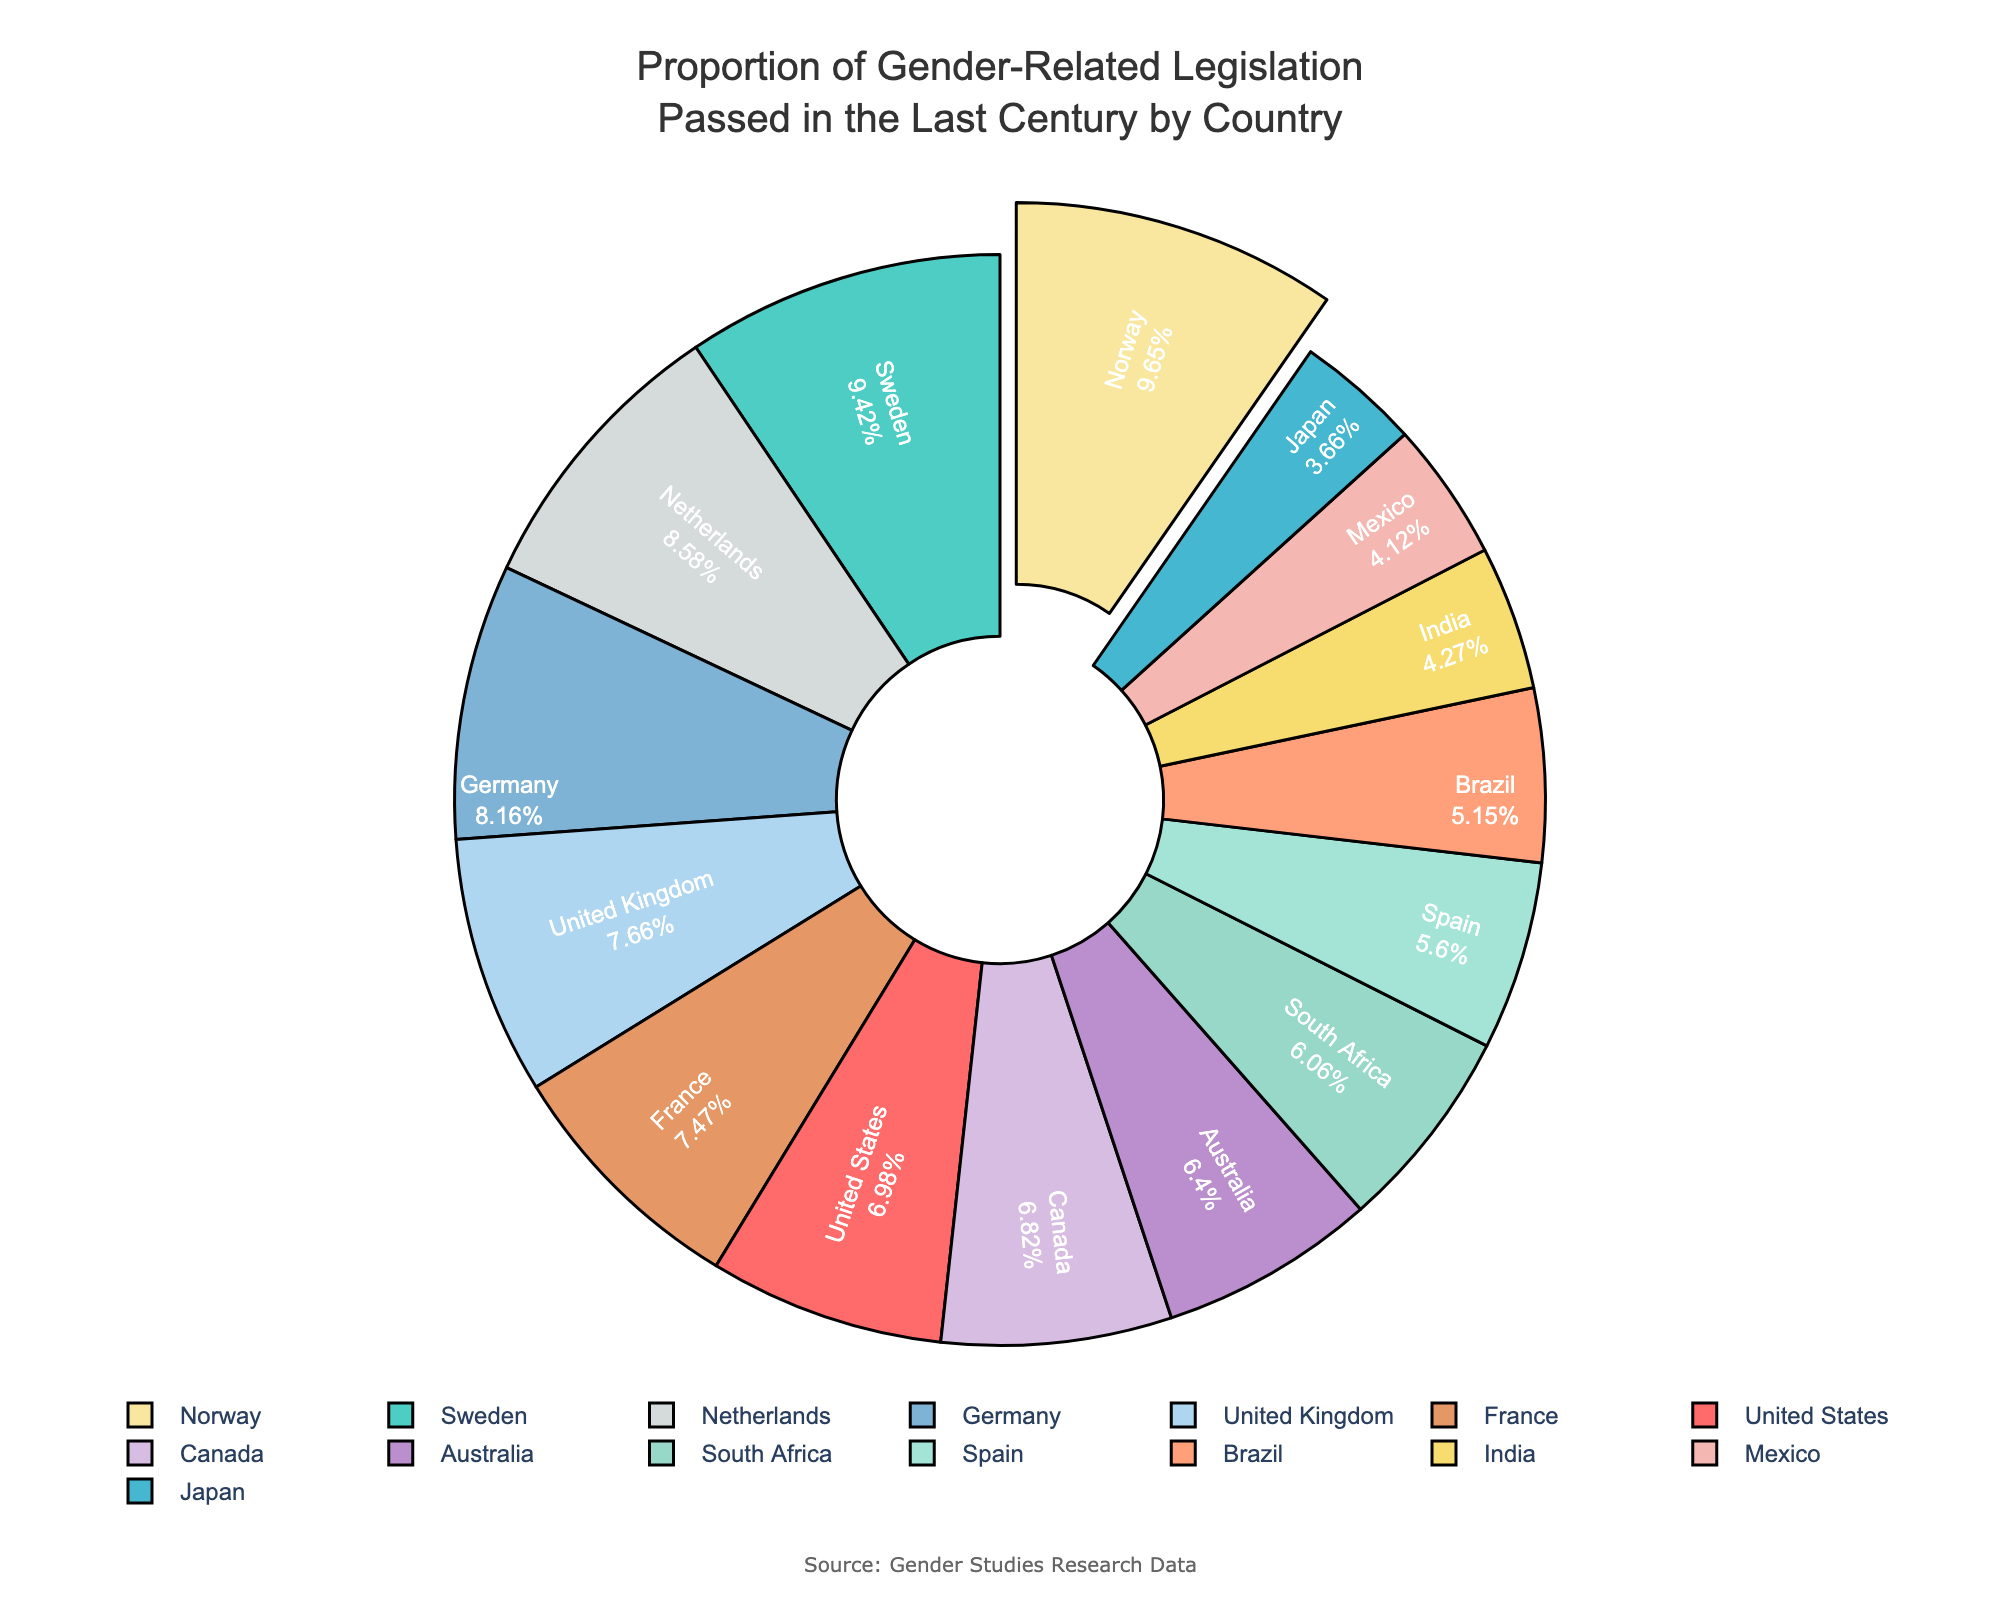Which country has the highest proportion of gender-related legislation passed in the last century? Identify the country represented by the largest slice of the pie chart.
Answer: Norway What is the percentage of gender-related legislation passed in Japan compared to Brazil? Look at the percentages for Japan and Brazil. Japan has 9.6% and Brazil has 13.5%. Compare the two values to determine which is smaller.
Answer: Japan has a smaller percentage compared to Brazil How many countries have a proportion of gender-related legislation greater than 20%? Identify the countries with slices greater than 20%: Sweden (24.7%), Norway (25.3%), Germany (21.4%), and Netherlands (22.5%). Count these countries.
Answer: 4 What is the combined percentage of gender-related legislation passed in the United Kingdom and Germany? Sum the percentages of the United Kingdom (20.1%) and Germany (21.4%). 20.1 + 21.4 = 41.5
Answer: 41.5% Which three countries have the lowest proportion of gender-related legislation? Identify the smallest slices in the pie chart: Japan (9.6%), Mexico (10.8%), India (11.2%).
Answer: Japan, Mexico, India Which country has a slightly lower proportion of gender-related legislation passed than the United States? Compare the countries with percentages close to the United States' 18.3%. Canada has 17.9%, which is slightly lower.
Answer: Canada What is the average percentage of gender-related legislation passed by South Africa, Spain, and Mexico? Sum the percentages of South Africa (15.9%), Spain (14.7%), and Mexico (10.8%) and then divide by 3. (15.9 + 14.7 + 10.8) / 3 = 13.8
Answer: 13.8% How does the proportion of gender-related legislation in India compare with Australia? Compare the percentages: India has 11.2% and Australia has 16.8%. Australia has a higher proportion than India.
Answer: Australia has a higher proportion What is the difference in proportion between France and the United States? Subtract the percentage of the United States (18.3%) from France (19.6%). 19.6 - 18.3 = 1.3
Answer: 1.3% Which country represented in blue has a higher proportion of gender-related legislation, Germany or the Netherlands? Identify the countries with blue-colored slices. Compare the percentages. Germany has 21.4% and Netherlands has 22.5%. The Netherlands has a higher proportion.
Answer: Netherlands 